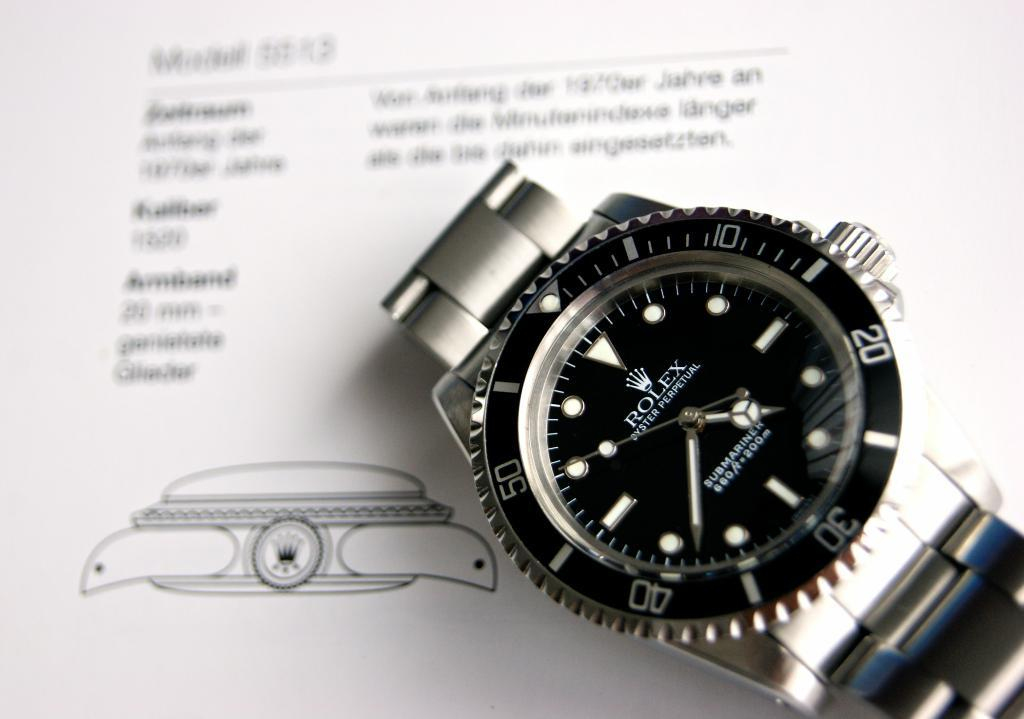<image>
Provide a brief description of the given image. A Rolex Oyster Perpetual watch o a vague schemati of itself. 